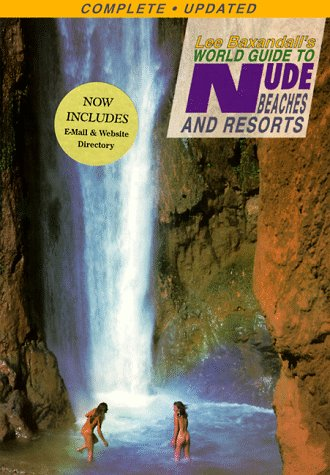What is the title of this book? The title is 'Lee Baxandall's World Guide to Nude Beaches & Resorts, Updated Edition', detailing various nudist-friendly destinations. 